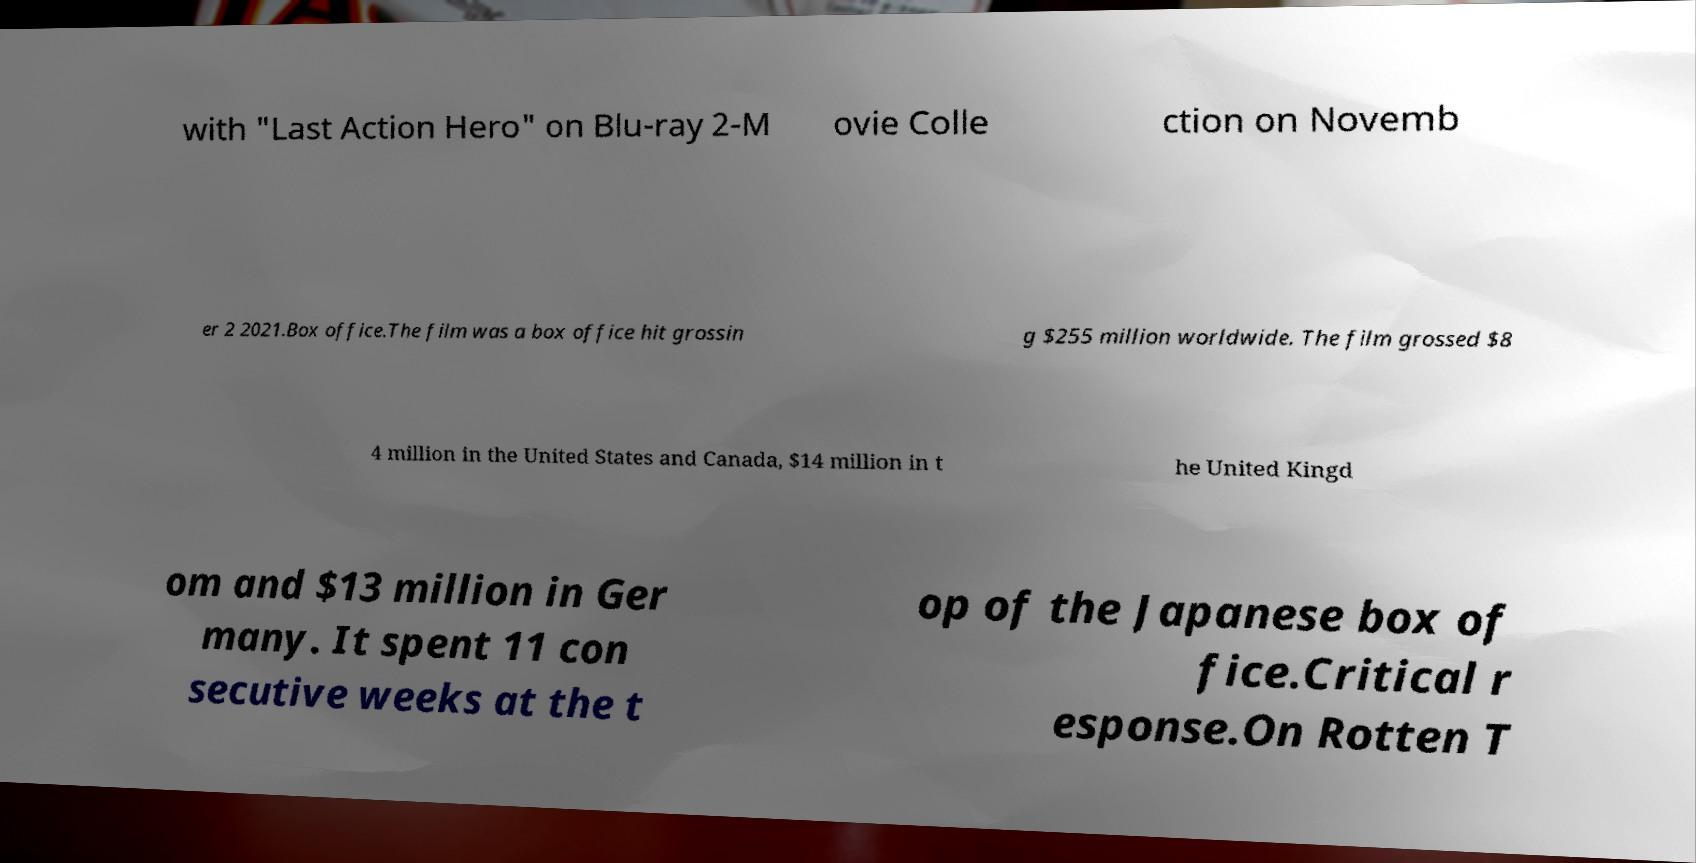Please read and relay the text visible in this image. What does it say? with "Last Action Hero" on Blu-ray 2-M ovie Colle ction on Novemb er 2 2021.Box office.The film was a box office hit grossin g $255 million worldwide. The film grossed $8 4 million in the United States and Canada, $14 million in t he United Kingd om and $13 million in Ger many. It spent 11 con secutive weeks at the t op of the Japanese box of fice.Critical r esponse.On Rotten T 